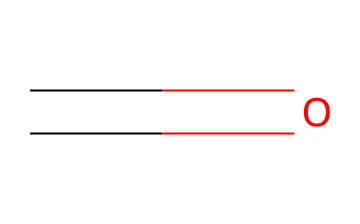What is the chemical name of this structure? The chemical structure represented by the SMILES "C=O" indicates a molecule with a carbon atom double-bonded to an oxygen atom. This is characteristic of aldehydes, and the simplest aldehyde is formaldehyde.
Answer: formaldehyde How many carbon atoms are present in this molecule? The SMILES representation "C=O" shows that there is one carbon atom (C) in the structure. The '=' indicates a double bond to the oxygen, but does not add any additional carbon atoms.
Answer: one What functional group is present in this chemical? The chemical structure features a carbon atom double-bonded to an oxygen atom, which represents the carbonyl functional group. Since it is at the end of a carbon chain, this structure is specific to aldehydes.
Answer: carbonyl Is the chemical represented a saturated or unsaturated compound? The presence of a double bond between the carbon and oxygen in the SMILES "C=O" indicates that it is an unsaturated compound. Saturated compounds have only single bonds.
Answer: unsaturated What is the simplest aldehyde? The structure "C=O" represents the core structure of aldehydes, and the simplest form, which includes just one carbon and has the aldehyde functional group, is formaldehyde.
Answer: formaldehyde What type of reaction can this compound undergo due to its functional group? Aldehydes, including formaldehyde, can undergo oxidation reactions due to the presence of the carbonyl group. This property facilitates various chemical transformations.
Answer: oxidation 